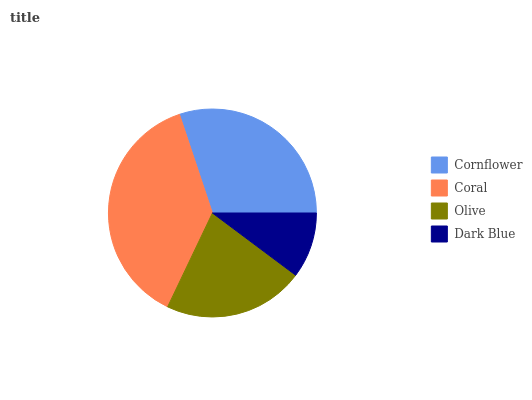Is Dark Blue the minimum?
Answer yes or no. Yes. Is Coral the maximum?
Answer yes or no. Yes. Is Olive the minimum?
Answer yes or no. No. Is Olive the maximum?
Answer yes or no. No. Is Coral greater than Olive?
Answer yes or no. Yes. Is Olive less than Coral?
Answer yes or no. Yes. Is Olive greater than Coral?
Answer yes or no. No. Is Coral less than Olive?
Answer yes or no. No. Is Cornflower the high median?
Answer yes or no. Yes. Is Olive the low median?
Answer yes or no. Yes. Is Coral the high median?
Answer yes or no. No. Is Dark Blue the low median?
Answer yes or no. No. 